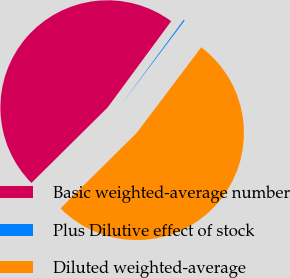Convert chart. <chart><loc_0><loc_0><loc_500><loc_500><pie_chart><fcel>Basic weighted-average number<fcel>Plus Dilutive effect of stock<fcel>Diluted weighted-average<nl><fcel>47.53%<fcel>0.18%<fcel>52.29%<nl></chart> 